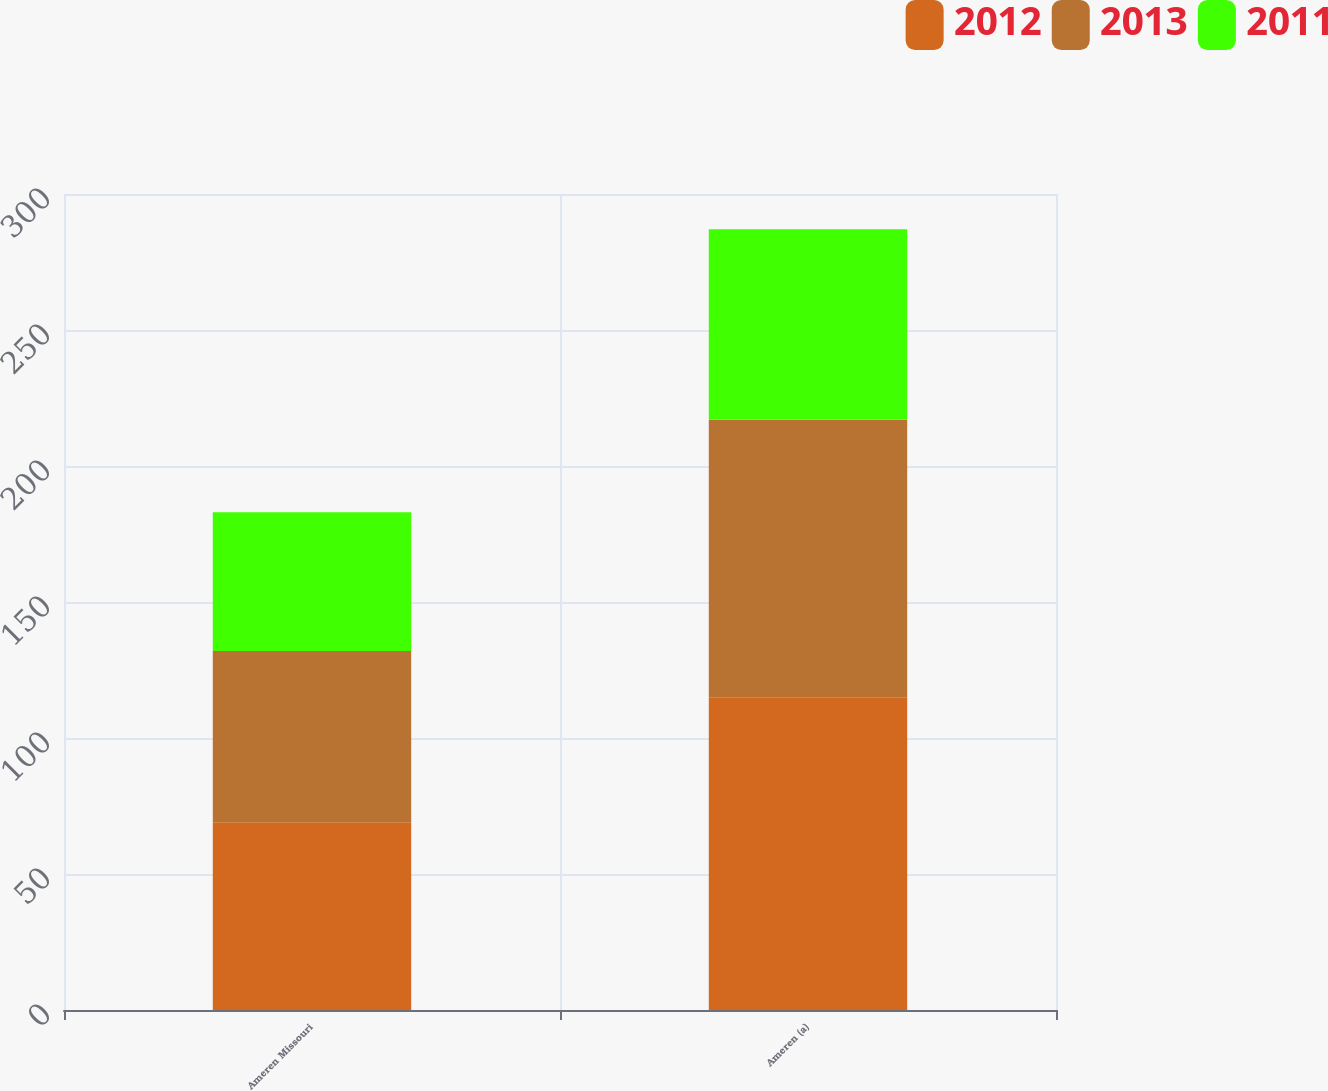<chart> <loc_0><loc_0><loc_500><loc_500><stacked_bar_chart><ecel><fcel>Ameren Missouri<fcel>Ameren (a)<nl><fcel>2012<fcel>69<fcel>115<nl><fcel>2013<fcel>63<fcel>102<nl><fcel>2011<fcel>51<fcel>70<nl></chart> 